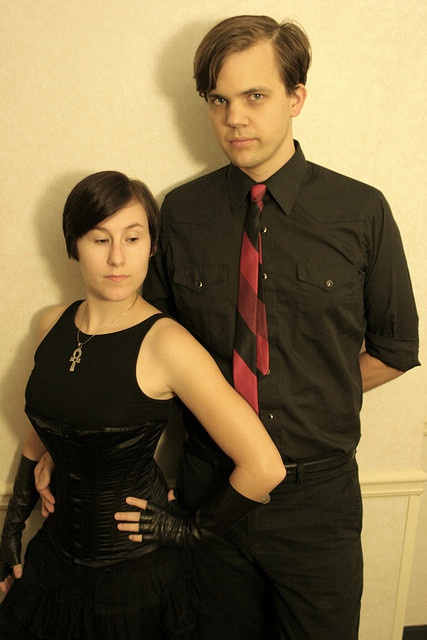Describe the objects in this image and their specific colors. I can see people in tan, black, maroon, and brown tones, people in tan, black, gray, and maroon tones, and tie in tan, black, brown, and maroon tones in this image. 